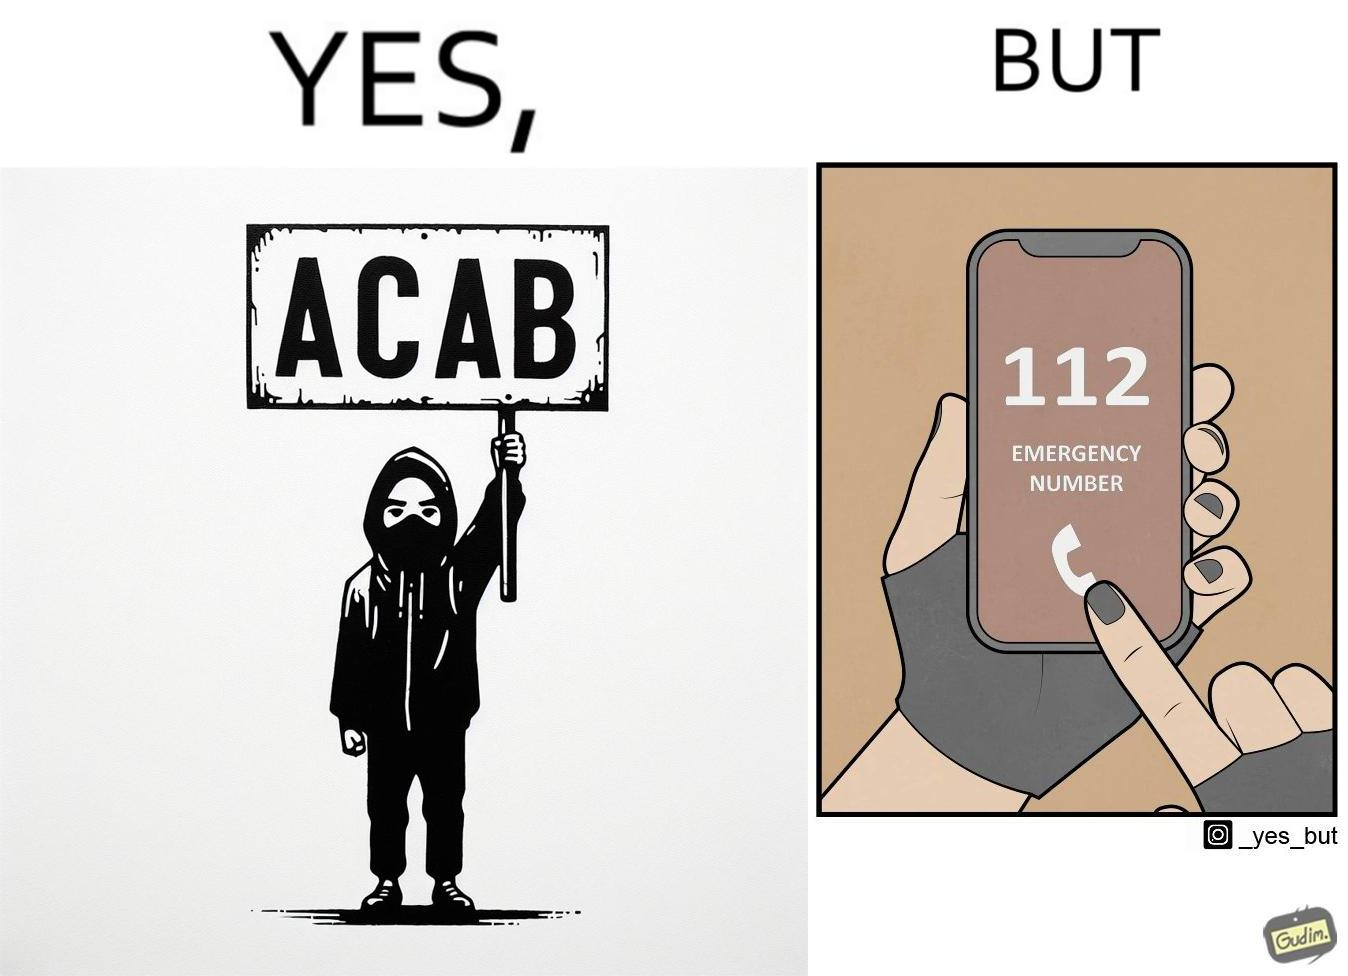What is shown in the left half versus the right half of this image? In the left part of the image: A person holding a sign that says the letters ACAB. The persons face is covered by a mask, they have black nails and they looks like they are protesting something. In the right part of the image: Person dialling 112 Emergency number on their phone. They have black nails 